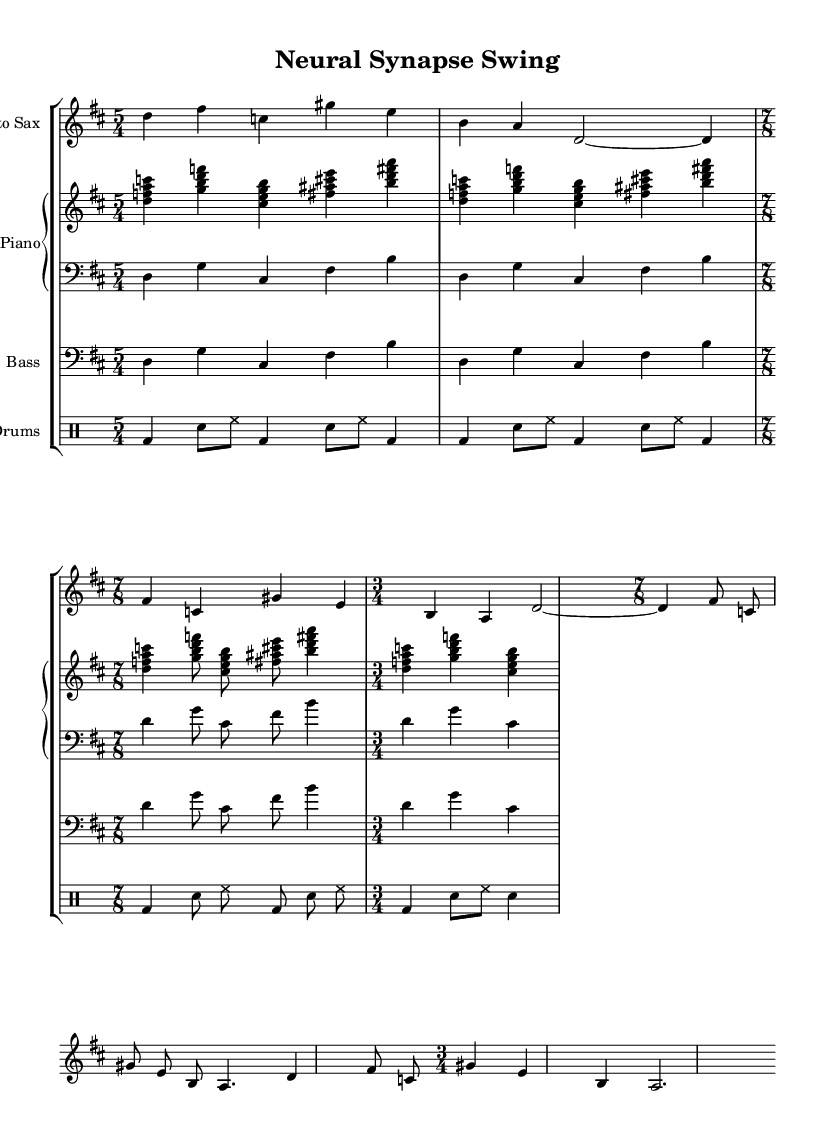What is the time signature of this music? The time signature is marked at the beginning of the score and includes 5/4, 7/8, and 3/4 time signatures. The initial indication is 5/4, followed by changes to 7/8 and then 3/4 in various sections.
Answer: 5/4, 7/8, 3/4 What is the key signature of this music? The key signature is indicated with sharps or flats at the beginning of the staff. In this score, the key signature is D major, which has two sharps.
Answer: D major What is the tempo marking for this piece? The tempo marking is defined at the start with a metronome marking. In this music, the tempo is set to a quarter note equals 90 beats per minute.
Answer: 90 Which instrument is featured at the beginning of the score? Instruments are listed with their names at the start of each staff. The first instrument in this score is the Alto Saxophone, as indicated by the header above that staff.
Answer: Alto Sax How many times does the bass music repeat in the first section? The bass part can be analyzed by counting the number of bars. The bass section consists of 8 bars that repeat over two measures, indicating it plays through the same pattern repeatedly.
Answer: 2 What is the style of this jazz piece? The style is determined by the overall structure and complexity of the music. This piece is avant-garde jazz, characterized by innovative rhythms and harmonies, inspired by neural network patterns as noted in the title and structure.
Answer: Avant-garde jazz How do the rhythmic patterns in the drum part contribute to the overall feel of the piece? The drum part includes various combinations of bass drum, snare, and hi-hat patterns. The varying subdivisions, especially in the 7/8 section, create a syncopated and complex rhythmic feel which is typical in avant-garde jazz.
Answer: Complex rhythmic feel 